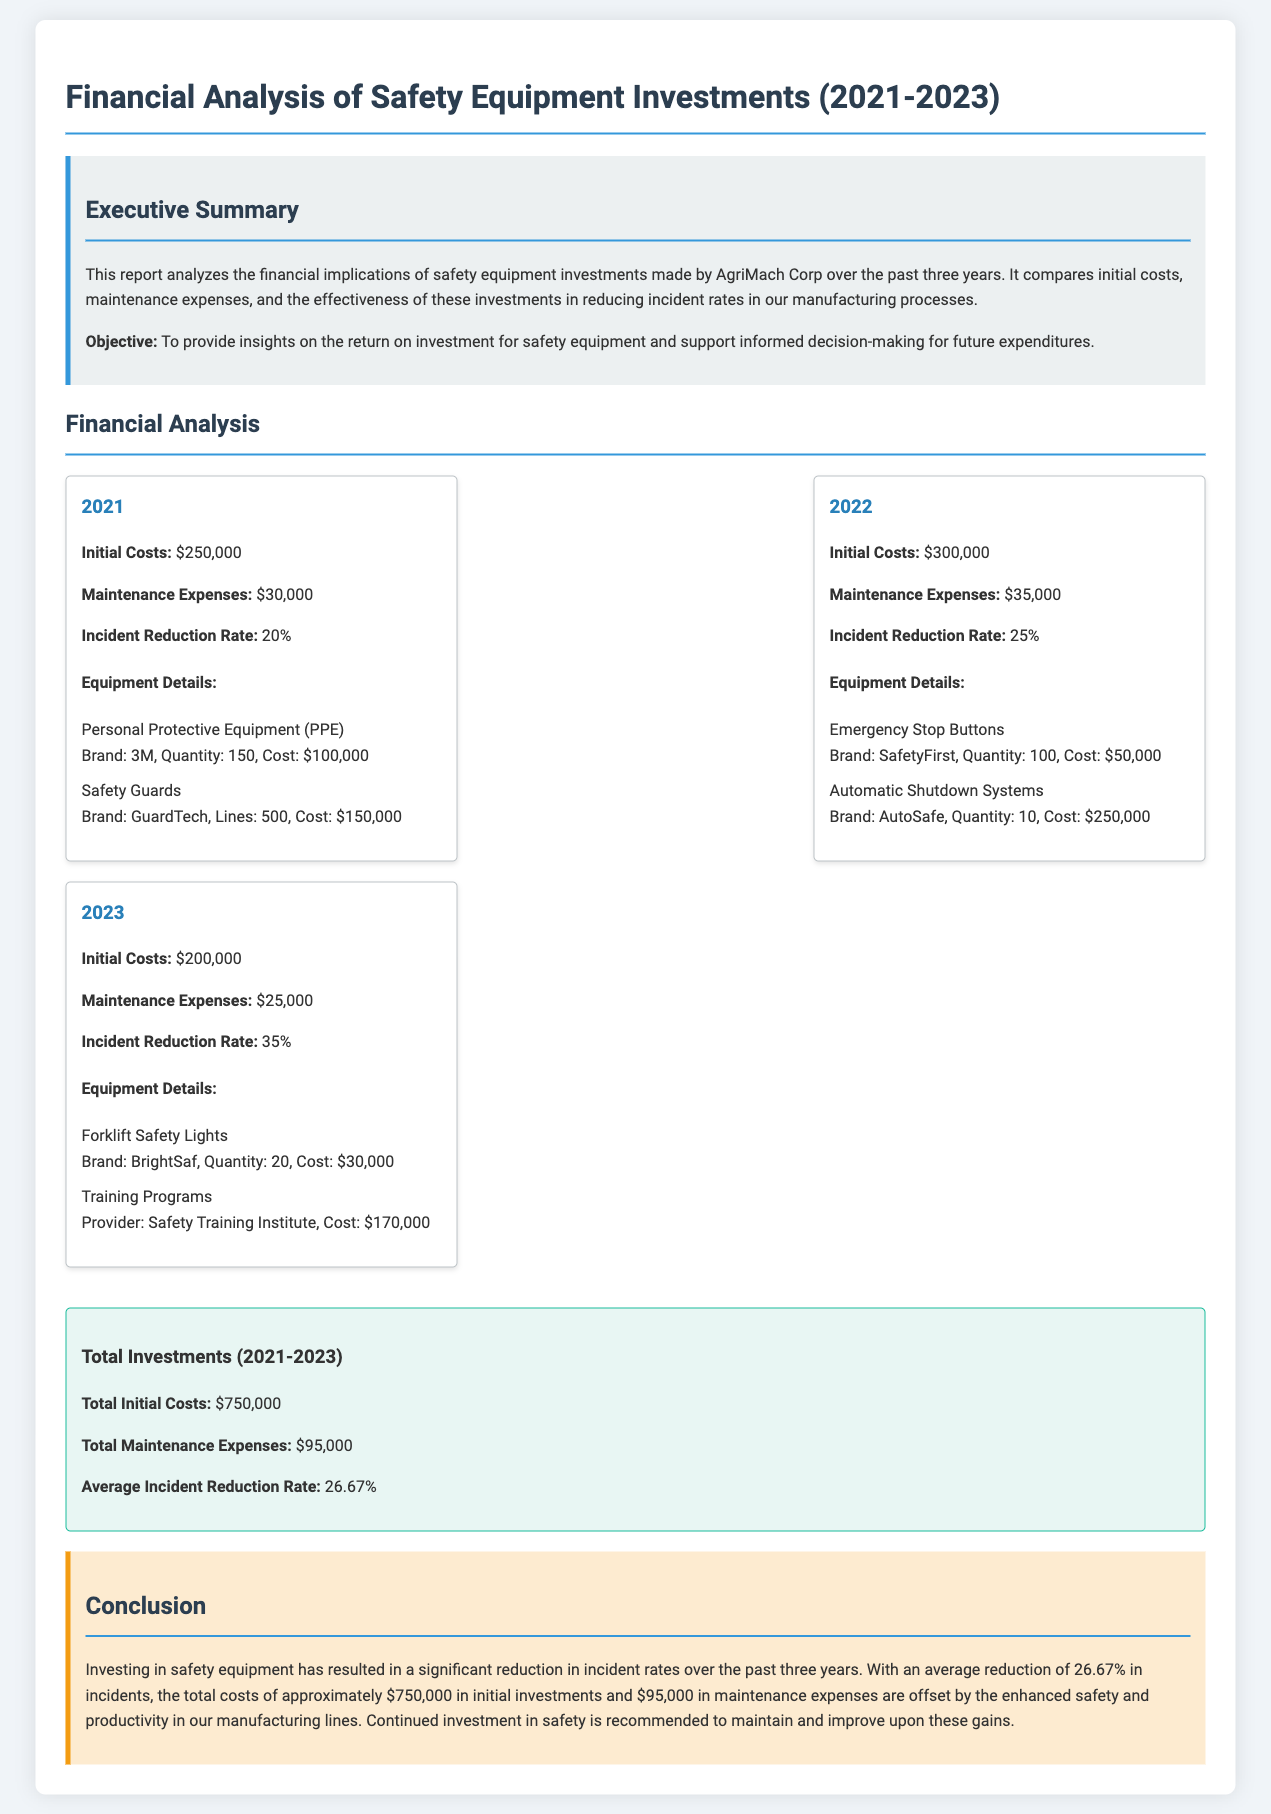What were the initial costs in 2021? Initial costs for 2021 are stated as $250,000 in the financial analysis section.
Answer: $250,000 What was the maintenance expense for the year 2022? The document specifies that the maintenance expenses for 2022 were $35,000.
Answer: $35,000 What is the incident reduction rate for 2023? The incident reduction rate for 2023 is mentioned as 35% in the analysis section.
Answer: 35% Which equipment had the highest initial cost in 2022? The equipment with the highest initial cost in 2022 is the Automatic Shutdown Systems with a cost of $250,000.
Answer: Automatic Shutdown Systems What is the total amount spent on maintenance expenses from 2021 to 2023? Total maintenance expenses from all years are reported as $95,000, calculated from individual annual expenses.
Answer: $95,000 What brand produced the Forklift Safety Lights? The document mentions BrightSaf as the brand for Forklift Safety Lights in the details for 2023.
Answer: BrightSaf What is the average incident reduction rate over the three years? The average incident reduction rate is calculated at 26.67% according to the total investments section.
Answer: 26.67% What is the conclusion regarding the investment in safety equipment? The conclusion states that continued investment in safety is recommended to maintain and improve gains observed.
Answer: Continued investment recommended What type of report is this document? The document type is a financial report that analyzes safety equipment investments.
Answer: Financial report 